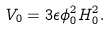<formula> <loc_0><loc_0><loc_500><loc_500>V _ { 0 } = 3 \epsilon \phi _ { 0 } ^ { 2 } H _ { 0 } ^ { 2 } .</formula> 